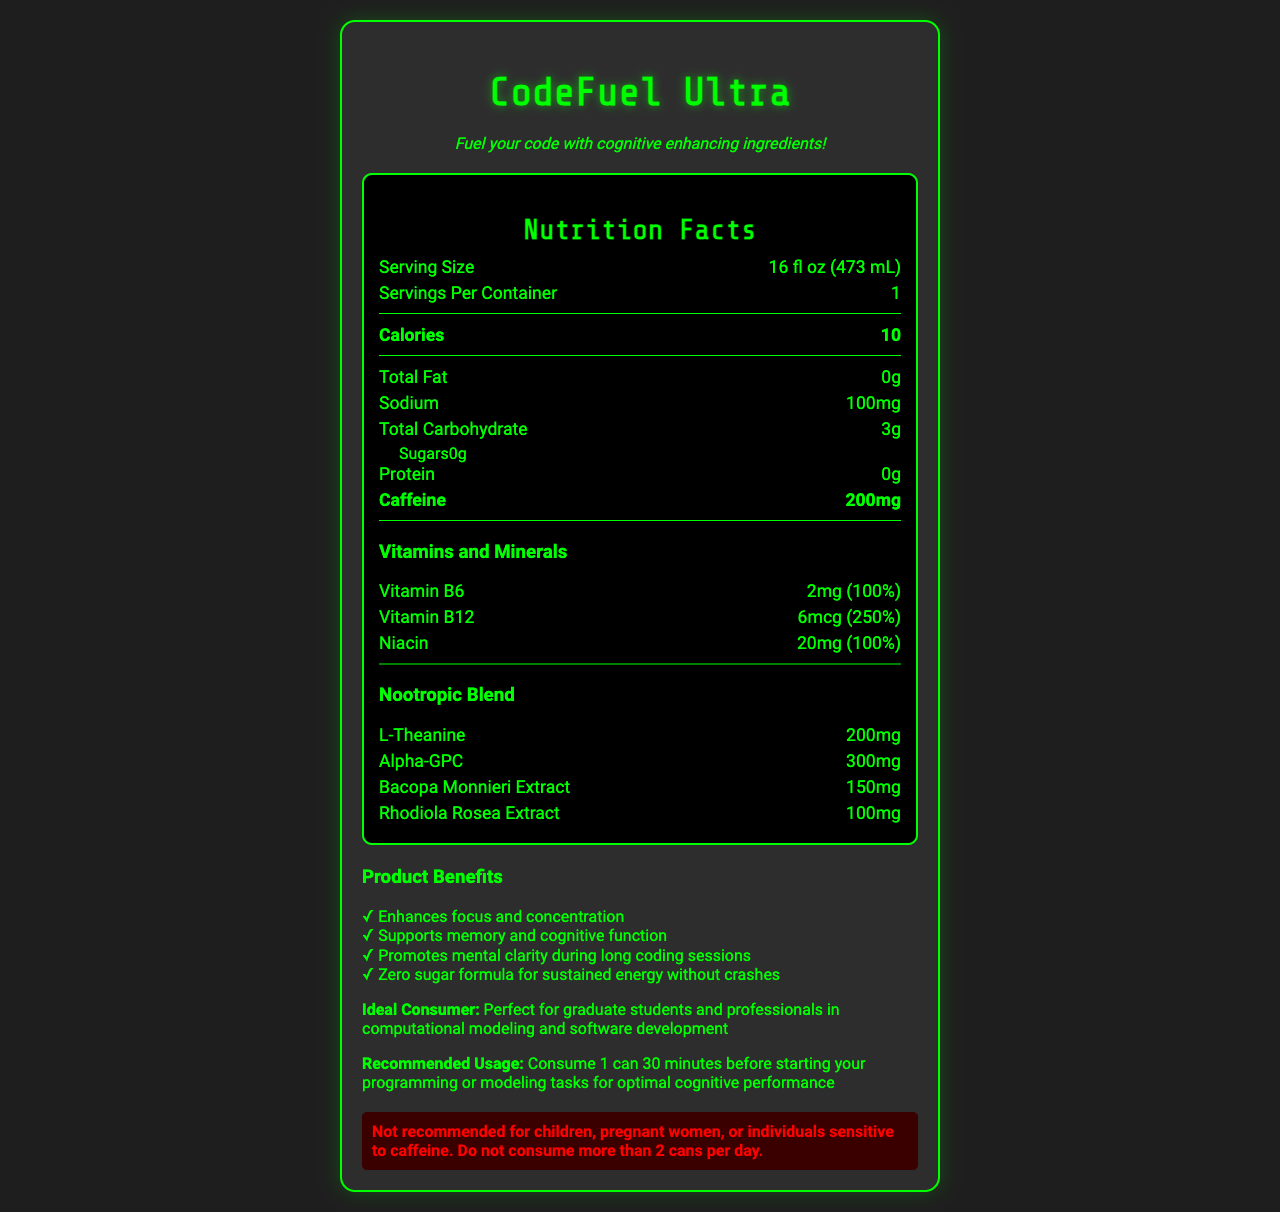what is the serving size of CodeFuel Ultra? The serving size is explicitly stated in the nutrition facts section of the document as 16 fl oz (473 mL).
Answer: 16 fl oz (473 mL) how much caffeine does a serving of CodeFuel Ultra contain? The caffeine content per serving is listed clearly in the nutrition facts section as 200mg.
Answer: 200mg which vitamins are included in CodeFuel Ultra? The vitamins included are listed in the vitamins and minerals section of the nutrition facts.
Answer: Vitamin B6, Vitamin B12, Niacin how much sodium is in a serving of CodeFuel Ultra? The sodium content per serving is listed in the nutrition facts section as 100mg.
Answer: 100mg how many calories does CodeFuel Ultra contain per serving? The calorie content per serving is listed at the top of the nutrition facts section as 10 calories.
Answer: 10 which of the following nootropic ingredients is included in CodeFuel Ultra? A. Ginseng B. L-Theanine C. Caffeine D. Ginkgo Biloba The nootropic ingredients section lists L-Theanine, making it the correct answer.
Answer: B how much Vitamin B12 is in one serving of CodeFuel Ultra? A. 2mg B. 6mcg C. 100mg D. 20mg The nutrition facts label lists Vitamin B12 at 6mcg.
Answer: B is CodeFuel Ultra recommended for children? The warning section clearly states that it is not recommended for children.
Answer: No summarize the main idea of the document. The document provides a detailed description of the energy drink CodeFuel Ultra, highlighting its nutritional content, nootropic ingredients, benefits, ideal consumers, and recommended usage, along with specific health warnings.
Answer: CodeFuel Ultra is an energy drink targeted at computer programmers, featuring a blend of nootropic ingredients, vitamins, and high caffeine content. It promises to enhance cognitive functions, focus, memory, and mental clarity, especially useful for long coding sessions. It contains zero sugar, few calories, and comes with health warnings for certain groups. what are the specific benefits listed for the product? The benefits are explicitly listed under the "Product Benefits" section.
Answer: Enhances focus and concentration, Supports memory and cognitive function, Promotes mental clarity during long coding sessions, Zero sugar formula for sustained energy without crashes what is the recommended usage for optimal cognitive performance? The recommended usage information is mentioned under the "Recommended Usage" section.
Answer: Consume 1 can 30 minutes before starting your programming or modeling tasks what ingredients are in the nootropic blend? The ingredients and their amounts are listed under the “Nootropic Blend” section.
Answer: L-Theanine, Alpha-GPC, Bacopa Monnieri Extract, Rhodiola Rosea Extract what allergens are processed in the facility where CodeFuel Ultra is manufactured? This information is provided in the "Allergen Information" section of the label.
Answer: Milk, soy, and tree nuts how many servings are there per container of CodeFuel Ultra? The number of servings per container is clearly stated as 1 in the nutrition facts section.
Answer: 1 how many grams of total carbohydrates are in each serving of CodeFuel Ultra? The amount of total carbohydrates per serving is listed in the nutrition facts section as 3g.
Answer: 3g how many grams of protein are in each serving of CodeFuel Ultra? The amount of protein per serving is listed in the nutrition facts section as 0g.
Answer: 0g what type of product is CodeFuel Ultra? The document refers to CodeFuel Ultra as an energy drink with cognitive-enhancing ingredients.
Answer: Energy drink which ingredient is not mentioned in the nootropic blend? A. Alpha-GPC B. Bacopa Monnieri Extract C. L-Theanine D. Ginseng Ginseng is not mentioned in the nootropic blend; the others are listed.
Answer: D does CodeFuel Ultra contain any sugar? The nutrition facts label lists sugars as 0g, indicating no sugar content.
Answer: No who is the ideal consumer for CodeFuel Ultra? The ideal consumer information is provided under the "Ideal Consumer" section.
Answer: Graduate students and professionals in computational modeling and software development what is the daily value percentage for Vitamin B6 in CodeFuel Ultra? The daily value percentage for Vitamin B6 is listed as 100% in the vitamins and minerals section.
Answer: 100% explain why a pregnant woman should avoid consuming CodeFuel Ultra. The warning section explicitly states that it is not recommended for pregnant women due to its high caffeine content.
Answer: Pregnant women should avoid consuming CodeFuel Ultra because it contains high levels of caffeine, which is generally advised against during pregnancy due to potential health risks to both the mother and the baby. how many milligrams of Alpha-GPC are in CodeFuel Ultra? The amount of Alpha-GPC is listed under the "Nootropic Blend" section as 300mg.
Answer: 300mg what is the main marketing tagline for CodeFuel Ultra? The marketing tagline is prominently displayed at the beginning of the document.
Answer: Fuel your code with cognitive enhancing ingredients! what are the sweeteners listed in CodeFuel Ultra’s ingredients? The other ingredients section lists both Sucralose and Acesulfame Potassium as sweeteners.
Answer: Sucralose and Acesulfame Potassium can you determine the exact caffeine tolerance level for every individual from the document? The document provides a general warning about caffeine sensitivity but does not detail specific individual tolerance levels or personalized recommendations.
Answer: Not enough information 